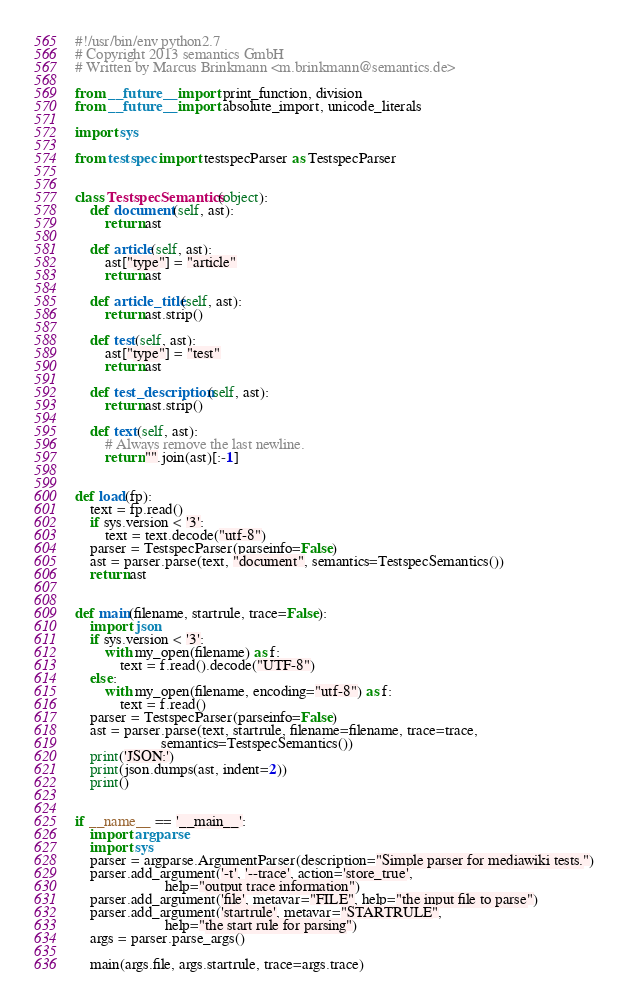Convert code to text. <code><loc_0><loc_0><loc_500><loc_500><_Python_>#!/usr/bin/env python2.7
# Copyright 2013 semantics GmbH
# Written by Marcus Brinkmann <m.brinkmann@semantics.de>

from __future__ import print_function, division
from __future__ import absolute_import, unicode_literals

import sys

from testspec import testspecParser as TestspecParser


class TestspecSemantics(object):
    def document(self, ast):
        return ast

    def article(self, ast):
        ast["type"] = "article"
        return ast

    def article_title(self, ast):
        return ast.strip()

    def test(self, ast):
        ast["type"] = "test"
        return ast

    def test_description(self, ast):
        return ast.strip()

    def text(self, ast):
        # Always remove the last newline.
        return "".join(ast)[:-1]


def load(fp):
    text = fp.read()
    if sys.version < '3':
        text = text.decode("utf-8")
    parser = TestspecParser(parseinfo=False)
    ast = parser.parse(text, "document", semantics=TestspecSemantics())
    return ast


def main(filename, startrule, trace=False):
    import json
    if sys.version < '3':
        with my_open(filename) as f:
            text = f.read().decode("UTF-8")
    else:
        with my_open(filename, encoding="utf-8") as f:
            text = f.read()
    parser = TestspecParser(parseinfo=False)
    ast = parser.parse(text, startrule, filename=filename, trace=trace,
                       semantics=TestspecSemantics())
    print('JSON:')
    print(json.dumps(ast, indent=2))
    print()


if __name__ == '__main__':
    import argparse
    import sys
    parser = argparse.ArgumentParser(description="Simple parser for mediawiki tests.")
    parser.add_argument('-t', '--trace', action='store_true',
                        help="output trace information")
    parser.add_argument('file', metavar="FILE", help="the input file to parse")
    parser.add_argument('startrule', metavar="STARTRULE",
                        help="the start rule for parsing")
    args = parser.parse_args()

    main(args.file, args.startrule, trace=args.trace)
</code> 